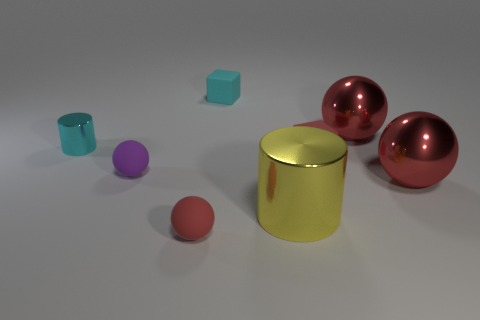Can you describe the texture of the large cylinder in the center? The large cylinder in the center has a reflective surface with a smooth metallic texture, giving off a shiny appearance with a golden-yellow sheen. 